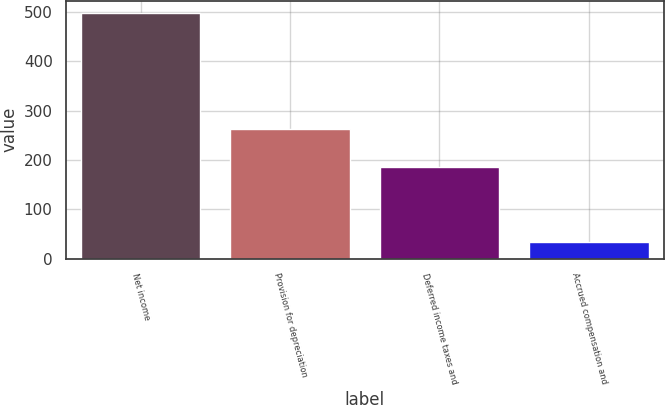Convert chart. <chart><loc_0><loc_0><loc_500><loc_500><bar_chart><fcel>Net income<fcel>Provision for depreciation<fcel>Deferred income taxes and<fcel>Accrued compensation and<nl><fcel>498<fcel>262<fcel>186<fcel>34<nl></chart> 